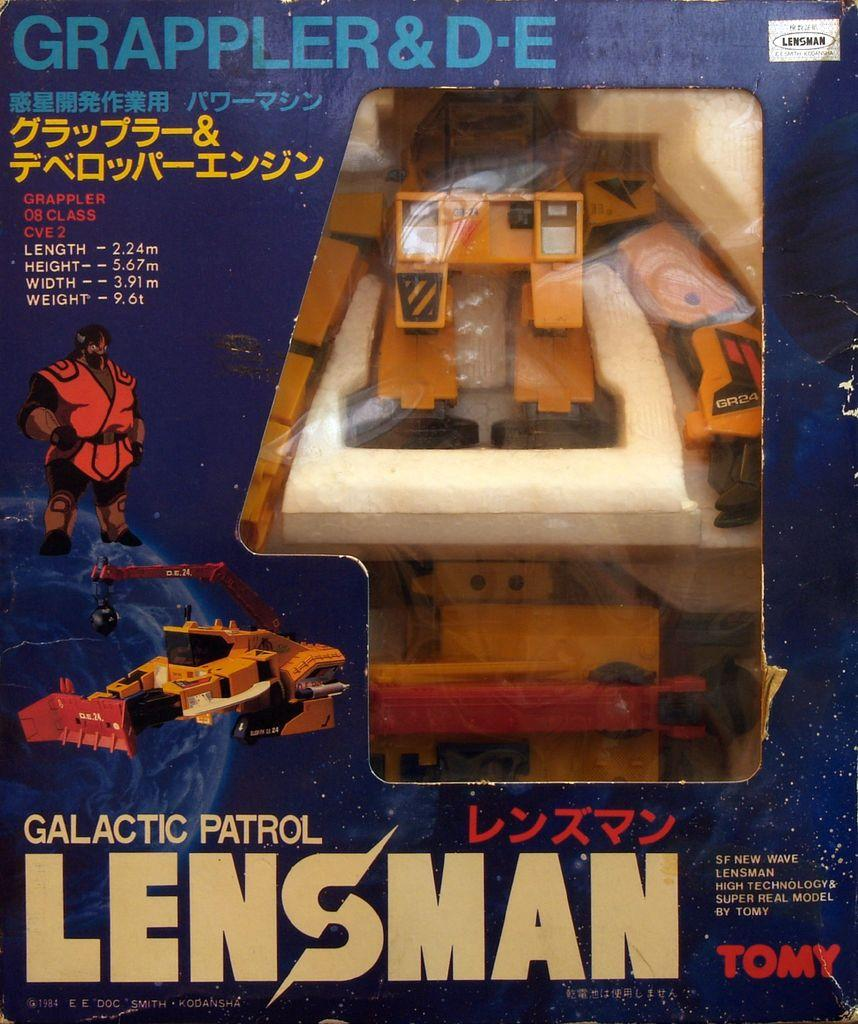<image>
Write a terse but informative summary of the picture. old toy from the brand galatic patrol lensman 